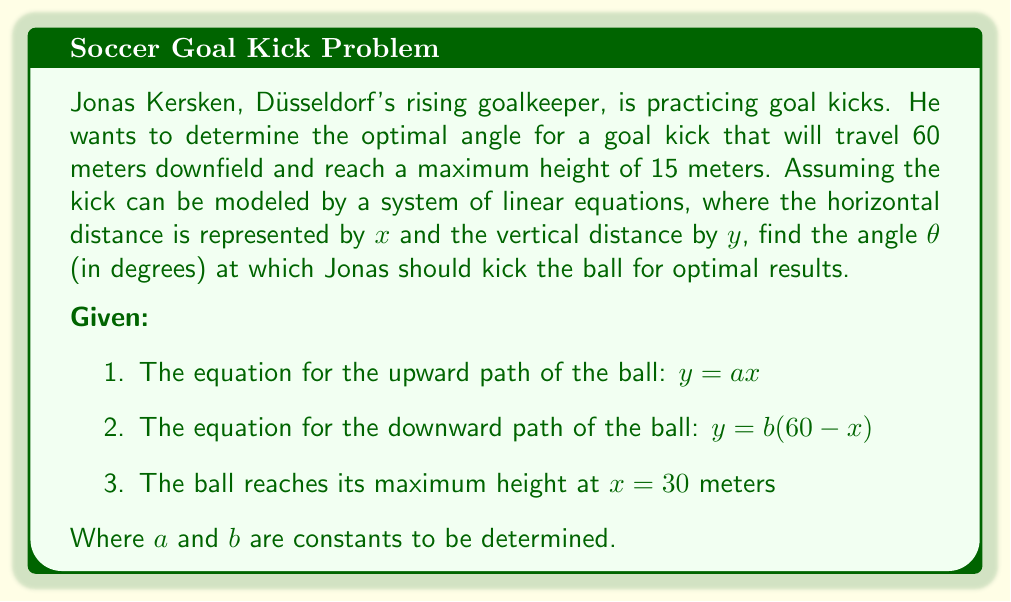Give your solution to this math problem. Let's solve this step-by-step:

1) At the highest point $(30, 15)$, both equations should give the same $y$ value:
   $15 = 30a$ and $15 = b(60-30)$

2) From these, we can find $a$ and $b$:
   $a = \frac{15}{30} = 0.5$ and $b = \frac{15}{30} = 0.5$

3) The equations of the paths are now:
   Upward: $y = 0.5x$
   Downward: $y = 0.5(60-x) = 30 - 0.5x$

4) The slope of the initial kick is equal to $a = 0.5$

5) The angle θ can be found using the arctangent function:
   $θ = \arctan(0.5)$

6) Convert radians to degrees:
   $θ = \arctan(0.5) \cdot \frac{180}{\pi}$

7) Calculate:
   $θ ≈ 26.57°$

Therefore, Jonas should kick the ball at an angle of approximately 26.57° for optimal results.
Answer: $26.57°$ 